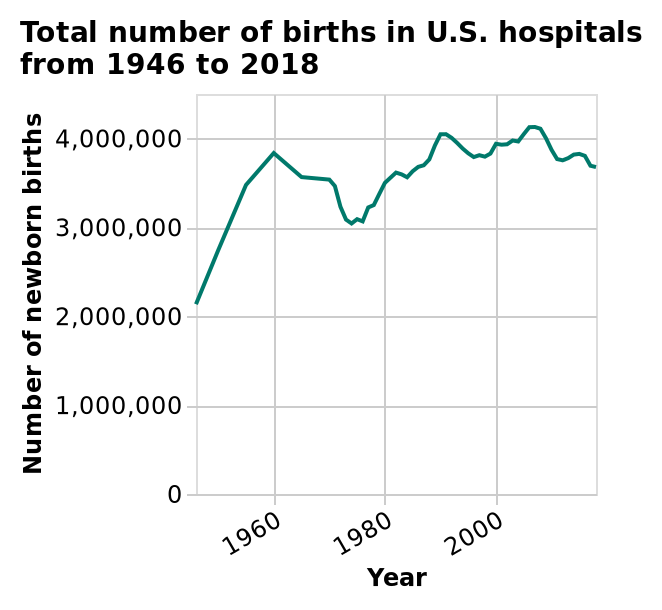<image>
What is the range of the y-axis in the line graph?  The range of the y-axis in the line graph is from 0 to 4,000,000. 